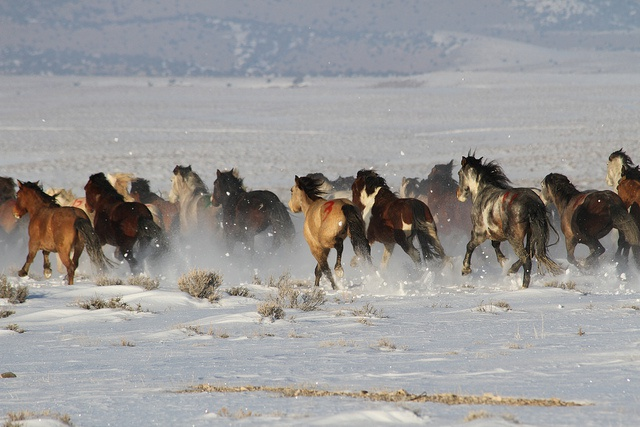Describe the objects in this image and their specific colors. I can see horse in gray and black tones, horse in gray, black, maroon, and darkgray tones, horse in gray, black, maroon, and darkgray tones, horse in gray, black, and maroon tones, and horse in gray, black, tan, and brown tones in this image. 